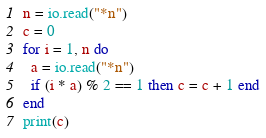<code> <loc_0><loc_0><loc_500><loc_500><_Lua_>n = io.read("*n")
c = 0
for i = 1, n do
  a = io.read("*n")
  if (i * a) % 2 == 1 then c = c + 1 end
end
print(c)
</code> 